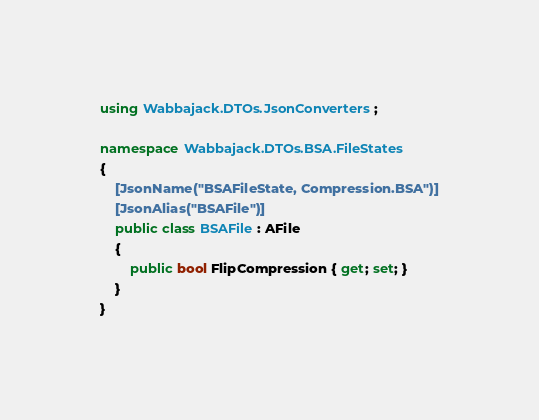<code> <loc_0><loc_0><loc_500><loc_500><_C#_>using Wabbajack.DTOs.JsonConverters;

namespace Wabbajack.DTOs.BSA.FileStates
{
    [JsonName("BSAFileState, Compression.BSA")]
    [JsonAlias("BSAFile")]
    public class BSAFile : AFile
    {
        public bool FlipCompression { get; set; }
    }
}</code> 